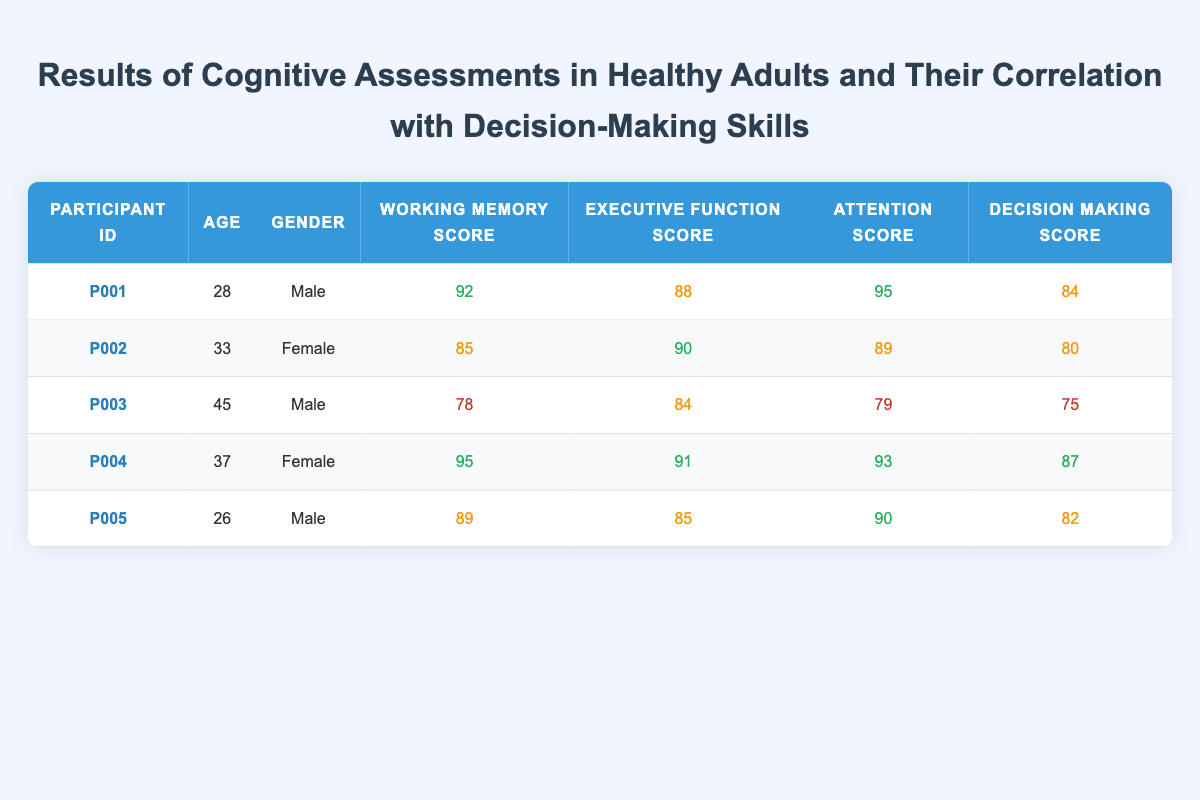What is the Working Memory Score of Participant P004? The table shows the score for each participant under the "Working Memory Score" column. For Participant P004, the score listed is 95.
Answer: 95 What is the average Decision Making Score among all participants? To calculate the average Decision Making Score, first, sum the scores: 84 + 80 + 75 + 87 + 82 = 408. Then, divide by the number of participants (5): 408 / 5 = 81.6.
Answer: 81.6 Is Participant P002 older than Participant P005? Participant P002 is 33 years old, while Participant P005 is 26 years old. Since 33 is greater than 26, the statement is true.
Answer: Yes Which participant has the highest Attention Score and what is that score? By examining the "Attention Score" column, Participant P001 has the highest score of 95.
Answer: P001, 95 What is the difference between the Decision Making Scores of the oldest and youngest participants? The oldest participant is P003 with a Decision Making Score of 75, while the youngest is P005 with a score of 82. The difference is calculated as 82 - 75 = 7.
Answer: 7 Are all participants with a Working Memory Score above 90 also achieving high scores (above 85) in Decision Making? Participants P001 and P004 have Working Memory Scores above 90. P001's Decision Making Score is 84 (not above 85), and P004's score is 87 (above 85). Therefore, not all participants above 90 in Working Memory meet the high score criterion in Decision Making.
Answer: No What is the gender distribution among the participants? There are 3 male participants (P001, P003, P005) and 2 female participants (P002, P004). This indicates a gender ratio of 60% male to 40% female in this sample.
Answer: 3 males, 2 females What is the average Executive Function Score for participants aged 35 and older? Participants P003 (45) and P004 (37) are aged 35 or older. Their Executive Function Scores are 84 and 91, respectively. The average is (84 + 91) / 2 = 87.5.
Answer: 87.5 